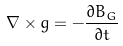<formula> <loc_0><loc_0><loc_500><loc_500>\nabla \times g = - \frac { \partial B _ { G } } { \partial t }</formula> 